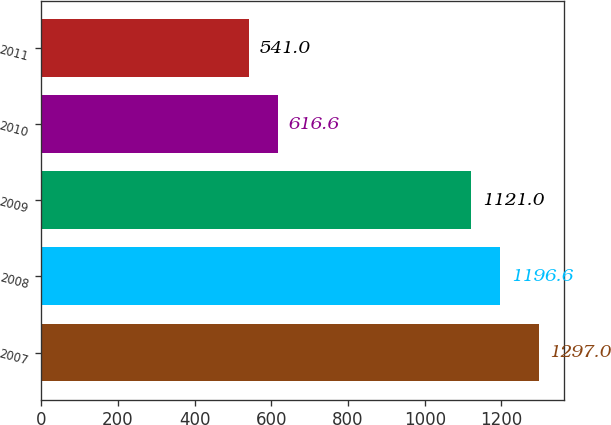<chart> <loc_0><loc_0><loc_500><loc_500><bar_chart><fcel>2007<fcel>2008<fcel>2009<fcel>2010<fcel>2011<nl><fcel>1297<fcel>1196.6<fcel>1121<fcel>616.6<fcel>541<nl></chart> 